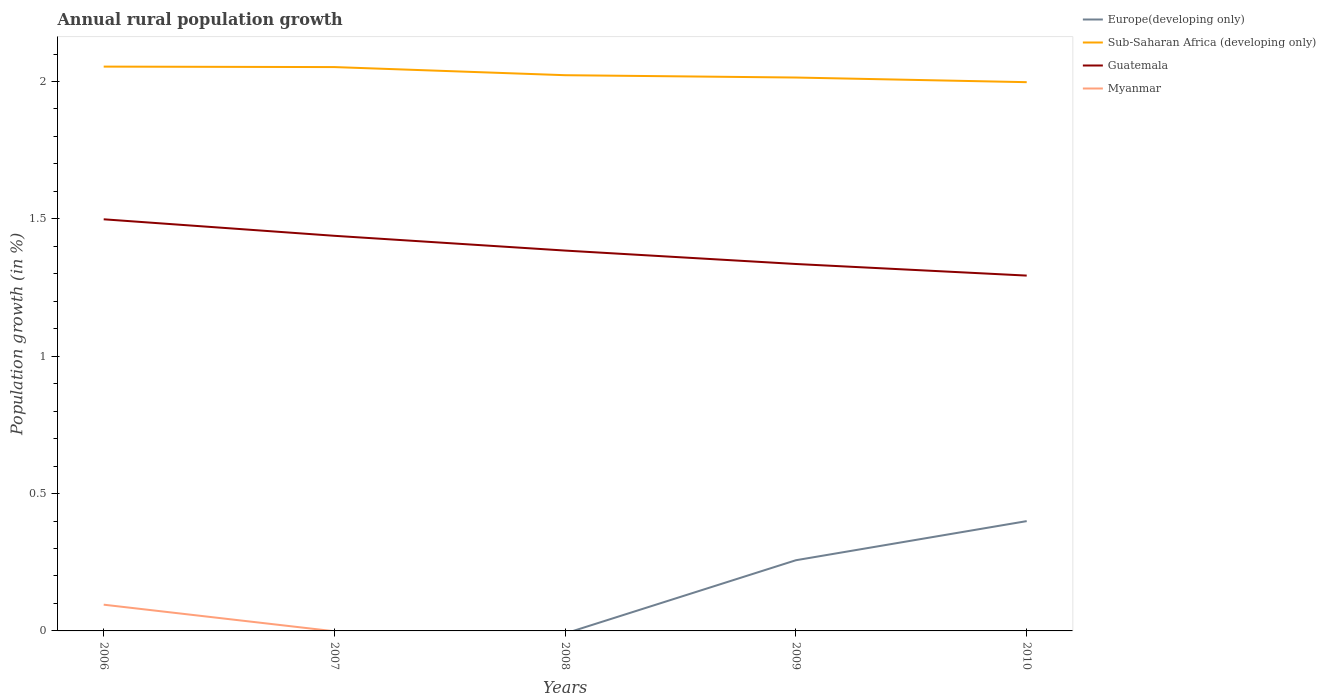What is the total percentage of rural population growth in Guatemala in the graph?
Give a very brief answer. 0.1. What is the difference between the highest and the second highest percentage of rural population growth in Myanmar?
Make the answer very short. 0.1. What is the difference between the highest and the lowest percentage of rural population growth in Sub-Saharan Africa (developing only)?
Offer a terse response. 2. Is the percentage of rural population growth in Guatemala strictly greater than the percentage of rural population growth in Europe(developing only) over the years?
Offer a terse response. No. What is the difference between two consecutive major ticks on the Y-axis?
Give a very brief answer. 0.5. Does the graph contain any zero values?
Your response must be concise. Yes. Does the graph contain grids?
Provide a short and direct response. No. What is the title of the graph?
Keep it short and to the point. Annual rural population growth. What is the label or title of the Y-axis?
Your answer should be compact. Population growth (in %). What is the Population growth (in %) in Europe(developing only) in 2006?
Offer a very short reply. 0. What is the Population growth (in %) in Sub-Saharan Africa (developing only) in 2006?
Your answer should be compact. 2.05. What is the Population growth (in %) in Guatemala in 2006?
Offer a terse response. 1.5. What is the Population growth (in %) in Myanmar in 2006?
Offer a very short reply. 0.1. What is the Population growth (in %) in Europe(developing only) in 2007?
Give a very brief answer. 0. What is the Population growth (in %) in Sub-Saharan Africa (developing only) in 2007?
Provide a succinct answer. 2.05. What is the Population growth (in %) in Guatemala in 2007?
Make the answer very short. 1.44. What is the Population growth (in %) of Myanmar in 2007?
Provide a succinct answer. 0. What is the Population growth (in %) in Europe(developing only) in 2008?
Offer a terse response. 0. What is the Population growth (in %) of Sub-Saharan Africa (developing only) in 2008?
Offer a very short reply. 2.02. What is the Population growth (in %) in Guatemala in 2008?
Ensure brevity in your answer.  1.38. What is the Population growth (in %) of Myanmar in 2008?
Your answer should be very brief. 0. What is the Population growth (in %) of Europe(developing only) in 2009?
Provide a succinct answer. 0.26. What is the Population growth (in %) of Sub-Saharan Africa (developing only) in 2009?
Give a very brief answer. 2.01. What is the Population growth (in %) in Guatemala in 2009?
Your answer should be compact. 1.34. What is the Population growth (in %) of Europe(developing only) in 2010?
Make the answer very short. 0.4. What is the Population growth (in %) in Sub-Saharan Africa (developing only) in 2010?
Give a very brief answer. 2. What is the Population growth (in %) in Guatemala in 2010?
Your answer should be very brief. 1.29. Across all years, what is the maximum Population growth (in %) in Europe(developing only)?
Your answer should be very brief. 0.4. Across all years, what is the maximum Population growth (in %) in Sub-Saharan Africa (developing only)?
Provide a succinct answer. 2.05. Across all years, what is the maximum Population growth (in %) of Guatemala?
Provide a short and direct response. 1.5. Across all years, what is the maximum Population growth (in %) in Myanmar?
Give a very brief answer. 0.1. Across all years, what is the minimum Population growth (in %) of Sub-Saharan Africa (developing only)?
Your answer should be very brief. 2. Across all years, what is the minimum Population growth (in %) of Guatemala?
Provide a succinct answer. 1.29. Across all years, what is the minimum Population growth (in %) in Myanmar?
Provide a short and direct response. 0. What is the total Population growth (in %) in Europe(developing only) in the graph?
Your answer should be very brief. 0.66. What is the total Population growth (in %) of Sub-Saharan Africa (developing only) in the graph?
Give a very brief answer. 10.14. What is the total Population growth (in %) in Guatemala in the graph?
Your answer should be compact. 6.95. What is the total Population growth (in %) of Myanmar in the graph?
Ensure brevity in your answer.  0.1. What is the difference between the Population growth (in %) in Sub-Saharan Africa (developing only) in 2006 and that in 2007?
Your response must be concise. 0. What is the difference between the Population growth (in %) in Guatemala in 2006 and that in 2007?
Give a very brief answer. 0.06. What is the difference between the Population growth (in %) of Sub-Saharan Africa (developing only) in 2006 and that in 2008?
Your response must be concise. 0.03. What is the difference between the Population growth (in %) of Guatemala in 2006 and that in 2008?
Your response must be concise. 0.11. What is the difference between the Population growth (in %) of Sub-Saharan Africa (developing only) in 2006 and that in 2009?
Keep it short and to the point. 0.04. What is the difference between the Population growth (in %) of Guatemala in 2006 and that in 2009?
Give a very brief answer. 0.16. What is the difference between the Population growth (in %) in Sub-Saharan Africa (developing only) in 2006 and that in 2010?
Your answer should be very brief. 0.06. What is the difference between the Population growth (in %) of Guatemala in 2006 and that in 2010?
Your response must be concise. 0.2. What is the difference between the Population growth (in %) of Sub-Saharan Africa (developing only) in 2007 and that in 2008?
Provide a short and direct response. 0.03. What is the difference between the Population growth (in %) in Guatemala in 2007 and that in 2008?
Offer a terse response. 0.05. What is the difference between the Population growth (in %) in Sub-Saharan Africa (developing only) in 2007 and that in 2009?
Keep it short and to the point. 0.04. What is the difference between the Population growth (in %) of Guatemala in 2007 and that in 2009?
Keep it short and to the point. 0.1. What is the difference between the Population growth (in %) in Sub-Saharan Africa (developing only) in 2007 and that in 2010?
Make the answer very short. 0.06. What is the difference between the Population growth (in %) in Guatemala in 2007 and that in 2010?
Your answer should be compact. 0.14. What is the difference between the Population growth (in %) of Sub-Saharan Africa (developing only) in 2008 and that in 2009?
Your response must be concise. 0.01. What is the difference between the Population growth (in %) of Guatemala in 2008 and that in 2009?
Your response must be concise. 0.05. What is the difference between the Population growth (in %) of Sub-Saharan Africa (developing only) in 2008 and that in 2010?
Your answer should be compact. 0.03. What is the difference between the Population growth (in %) in Guatemala in 2008 and that in 2010?
Offer a very short reply. 0.09. What is the difference between the Population growth (in %) of Europe(developing only) in 2009 and that in 2010?
Your response must be concise. -0.14. What is the difference between the Population growth (in %) in Sub-Saharan Africa (developing only) in 2009 and that in 2010?
Provide a short and direct response. 0.02. What is the difference between the Population growth (in %) in Guatemala in 2009 and that in 2010?
Offer a terse response. 0.04. What is the difference between the Population growth (in %) in Sub-Saharan Africa (developing only) in 2006 and the Population growth (in %) in Guatemala in 2007?
Ensure brevity in your answer.  0.62. What is the difference between the Population growth (in %) of Sub-Saharan Africa (developing only) in 2006 and the Population growth (in %) of Guatemala in 2008?
Your answer should be compact. 0.67. What is the difference between the Population growth (in %) in Sub-Saharan Africa (developing only) in 2006 and the Population growth (in %) in Guatemala in 2009?
Keep it short and to the point. 0.72. What is the difference between the Population growth (in %) in Sub-Saharan Africa (developing only) in 2006 and the Population growth (in %) in Guatemala in 2010?
Keep it short and to the point. 0.76. What is the difference between the Population growth (in %) of Sub-Saharan Africa (developing only) in 2007 and the Population growth (in %) of Guatemala in 2008?
Provide a succinct answer. 0.67. What is the difference between the Population growth (in %) in Sub-Saharan Africa (developing only) in 2007 and the Population growth (in %) in Guatemala in 2009?
Make the answer very short. 0.72. What is the difference between the Population growth (in %) of Sub-Saharan Africa (developing only) in 2007 and the Population growth (in %) of Guatemala in 2010?
Your response must be concise. 0.76. What is the difference between the Population growth (in %) in Sub-Saharan Africa (developing only) in 2008 and the Population growth (in %) in Guatemala in 2009?
Offer a very short reply. 0.69. What is the difference between the Population growth (in %) in Sub-Saharan Africa (developing only) in 2008 and the Population growth (in %) in Guatemala in 2010?
Offer a terse response. 0.73. What is the difference between the Population growth (in %) in Europe(developing only) in 2009 and the Population growth (in %) in Sub-Saharan Africa (developing only) in 2010?
Make the answer very short. -1.74. What is the difference between the Population growth (in %) of Europe(developing only) in 2009 and the Population growth (in %) of Guatemala in 2010?
Your answer should be very brief. -1.04. What is the difference between the Population growth (in %) in Sub-Saharan Africa (developing only) in 2009 and the Population growth (in %) in Guatemala in 2010?
Offer a very short reply. 0.72. What is the average Population growth (in %) in Europe(developing only) per year?
Provide a succinct answer. 0.13. What is the average Population growth (in %) of Sub-Saharan Africa (developing only) per year?
Offer a terse response. 2.03. What is the average Population growth (in %) of Guatemala per year?
Offer a very short reply. 1.39. What is the average Population growth (in %) in Myanmar per year?
Your answer should be compact. 0.02. In the year 2006, what is the difference between the Population growth (in %) in Sub-Saharan Africa (developing only) and Population growth (in %) in Guatemala?
Your response must be concise. 0.56. In the year 2006, what is the difference between the Population growth (in %) of Sub-Saharan Africa (developing only) and Population growth (in %) of Myanmar?
Your answer should be very brief. 1.96. In the year 2006, what is the difference between the Population growth (in %) in Guatemala and Population growth (in %) in Myanmar?
Make the answer very short. 1.4. In the year 2007, what is the difference between the Population growth (in %) in Sub-Saharan Africa (developing only) and Population growth (in %) in Guatemala?
Offer a terse response. 0.61. In the year 2008, what is the difference between the Population growth (in %) in Sub-Saharan Africa (developing only) and Population growth (in %) in Guatemala?
Your response must be concise. 0.64. In the year 2009, what is the difference between the Population growth (in %) in Europe(developing only) and Population growth (in %) in Sub-Saharan Africa (developing only)?
Provide a succinct answer. -1.76. In the year 2009, what is the difference between the Population growth (in %) of Europe(developing only) and Population growth (in %) of Guatemala?
Provide a succinct answer. -1.08. In the year 2009, what is the difference between the Population growth (in %) of Sub-Saharan Africa (developing only) and Population growth (in %) of Guatemala?
Your response must be concise. 0.68. In the year 2010, what is the difference between the Population growth (in %) in Europe(developing only) and Population growth (in %) in Sub-Saharan Africa (developing only)?
Provide a succinct answer. -1.6. In the year 2010, what is the difference between the Population growth (in %) in Europe(developing only) and Population growth (in %) in Guatemala?
Your response must be concise. -0.89. In the year 2010, what is the difference between the Population growth (in %) of Sub-Saharan Africa (developing only) and Population growth (in %) of Guatemala?
Your answer should be compact. 0.7. What is the ratio of the Population growth (in %) in Sub-Saharan Africa (developing only) in 2006 to that in 2007?
Provide a succinct answer. 1. What is the ratio of the Population growth (in %) of Guatemala in 2006 to that in 2007?
Your response must be concise. 1.04. What is the ratio of the Population growth (in %) in Sub-Saharan Africa (developing only) in 2006 to that in 2008?
Provide a short and direct response. 1.02. What is the ratio of the Population growth (in %) in Guatemala in 2006 to that in 2008?
Offer a terse response. 1.08. What is the ratio of the Population growth (in %) in Sub-Saharan Africa (developing only) in 2006 to that in 2009?
Your response must be concise. 1.02. What is the ratio of the Population growth (in %) in Guatemala in 2006 to that in 2009?
Make the answer very short. 1.12. What is the ratio of the Population growth (in %) in Sub-Saharan Africa (developing only) in 2006 to that in 2010?
Your answer should be compact. 1.03. What is the ratio of the Population growth (in %) in Guatemala in 2006 to that in 2010?
Your answer should be very brief. 1.16. What is the ratio of the Population growth (in %) of Sub-Saharan Africa (developing only) in 2007 to that in 2008?
Your answer should be compact. 1.01. What is the ratio of the Population growth (in %) in Guatemala in 2007 to that in 2008?
Your response must be concise. 1.04. What is the ratio of the Population growth (in %) of Sub-Saharan Africa (developing only) in 2007 to that in 2009?
Make the answer very short. 1.02. What is the ratio of the Population growth (in %) of Guatemala in 2007 to that in 2009?
Provide a succinct answer. 1.08. What is the ratio of the Population growth (in %) of Sub-Saharan Africa (developing only) in 2007 to that in 2010?
Keep it short and to the point. 1.03. What is the ratio of the Population growth (in %) in Guatemala in 2007 to that in 2010?
Provide a short and direct response. 1.11. What is the ratio of the Population growth (in %) of Sub-Saharan Africa (developing only) in 2008 to that in 2009?
Give a very brief answer. 1. What is the ratio of the Population growth (in %) in Guatemala in 2008 to that in 2009?
Provide a short and direct response. 1.04. What is the ratio of the Population growth (in %) of Sub-Saharan Africa (developing only) in 2008 to that in 2010?
Provide a succinct answer. 1.01. What is the ratio of the Population growth (in %) in Guatemala in 2008 to that in 2010?
Keep it short and to the point. 1.07. What is the ratio of the Population growth (in %) of Europe(developing only) in 2009 to that in 2010?
Give a very brief answer. 0.64. What is the ratio of the Population growth (in %) of Sub-Saharan Africa (developing only) in 2009 to that in 2010?
Give a very brief answer. 1.01. What is the ratio of the Population growth (in %) of Guatemala in 2009 to that in 2010?
Provide a succinct answer. 1.03. What is the difference between the highest and the second highest Population growth (in %) of Sub-Saharan Africa (developing only)?
Offer a very short reply. 0. What is the difference between the highest and the second highest Population growth (in %) in Guatemala?
Ensure brevity in your answer.  0.06. What is the difference between the highest and the lowest Population growth (in %) in Europe(developing only)?
Provide a succinct answer. 0.4. What is the difference between the highest and the lowest Population growth (in %) of Sub-Saharan Africa (developing only)?
Your response must be concise. 0.06. What is the difference between the highest and the lowest Population growth (in %) in Guatemala?
Your answer should be compact. 0.2. What is the difference between the highest and the lowest Population growth (in %) of Myanmar?
Your answer should be very brief. 0.1. 